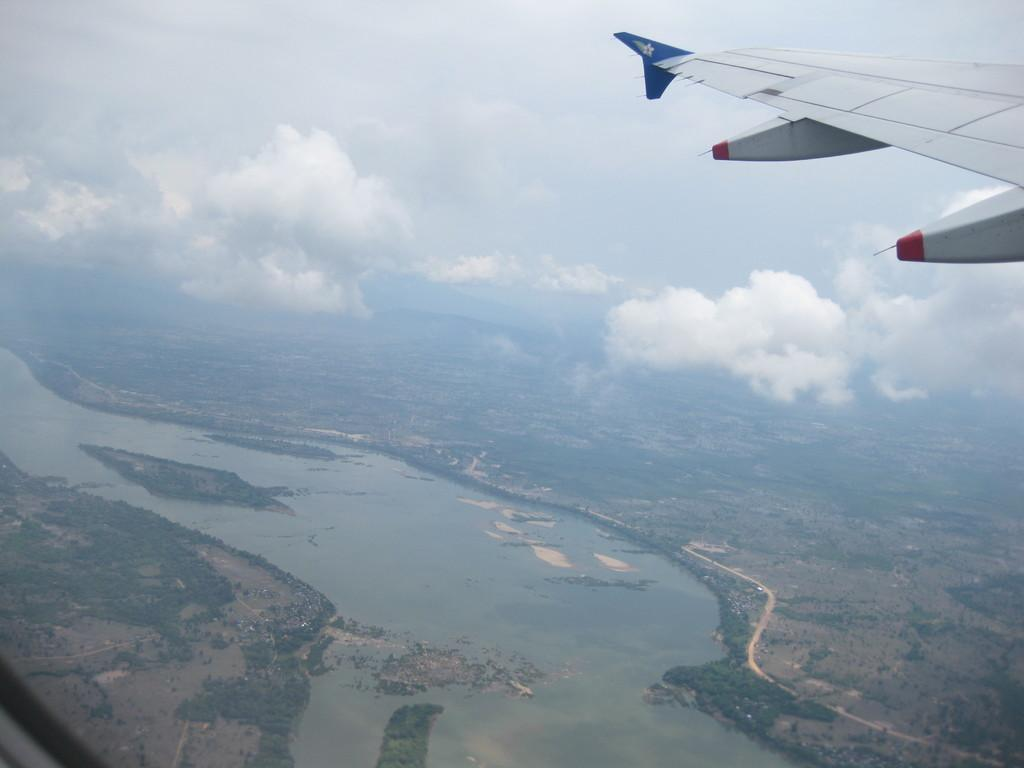What is the main subject of the image? The main subject of the image is an aircraft flying. What can be seen in the sky in the image? The sky is visible at the top of the image, and there are clouds present. What type of landscape is visible at the bottom of the image? There are trees, land, and water visible at the bottom of the image. What type of liquid is being poured from the aircraft in the image? There is no liquid being poured from the aircraft in the image; it is simply flying. Can you see any cornfields in the image? There are no cornfields present in the image. 